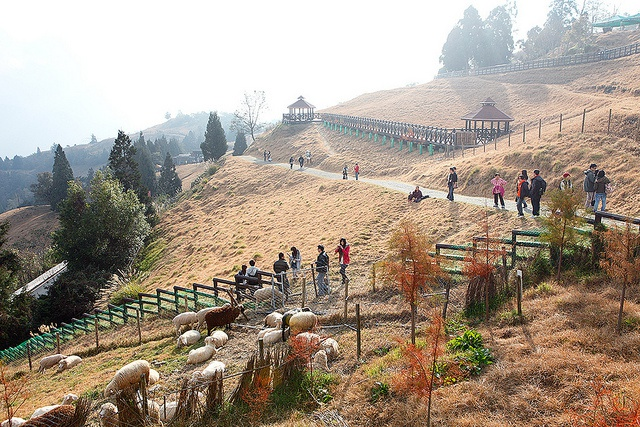Describe the objects in this image and their specific colors. I can see people in white, darkgray, gray, black, and tan tones, sheep in white, maroon, gray, and ivory tones, sheep in white, ivory, gray, darkgray, and maroon tones, sheep in white, black, maroon, and brown tones, and sheep in white, maroon, brown, gray, and tan tones in this image. 